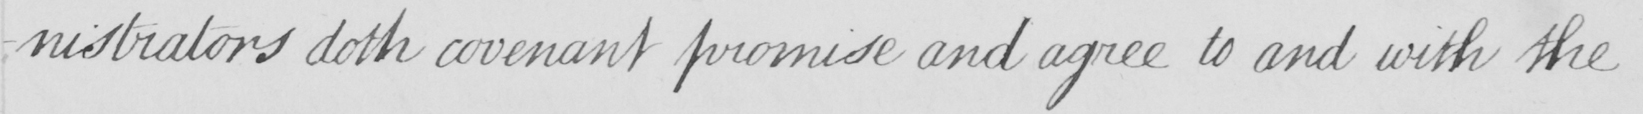Please transcribe the handwritten text in this image. -nistrators doth convenant promise and agree to and with the 